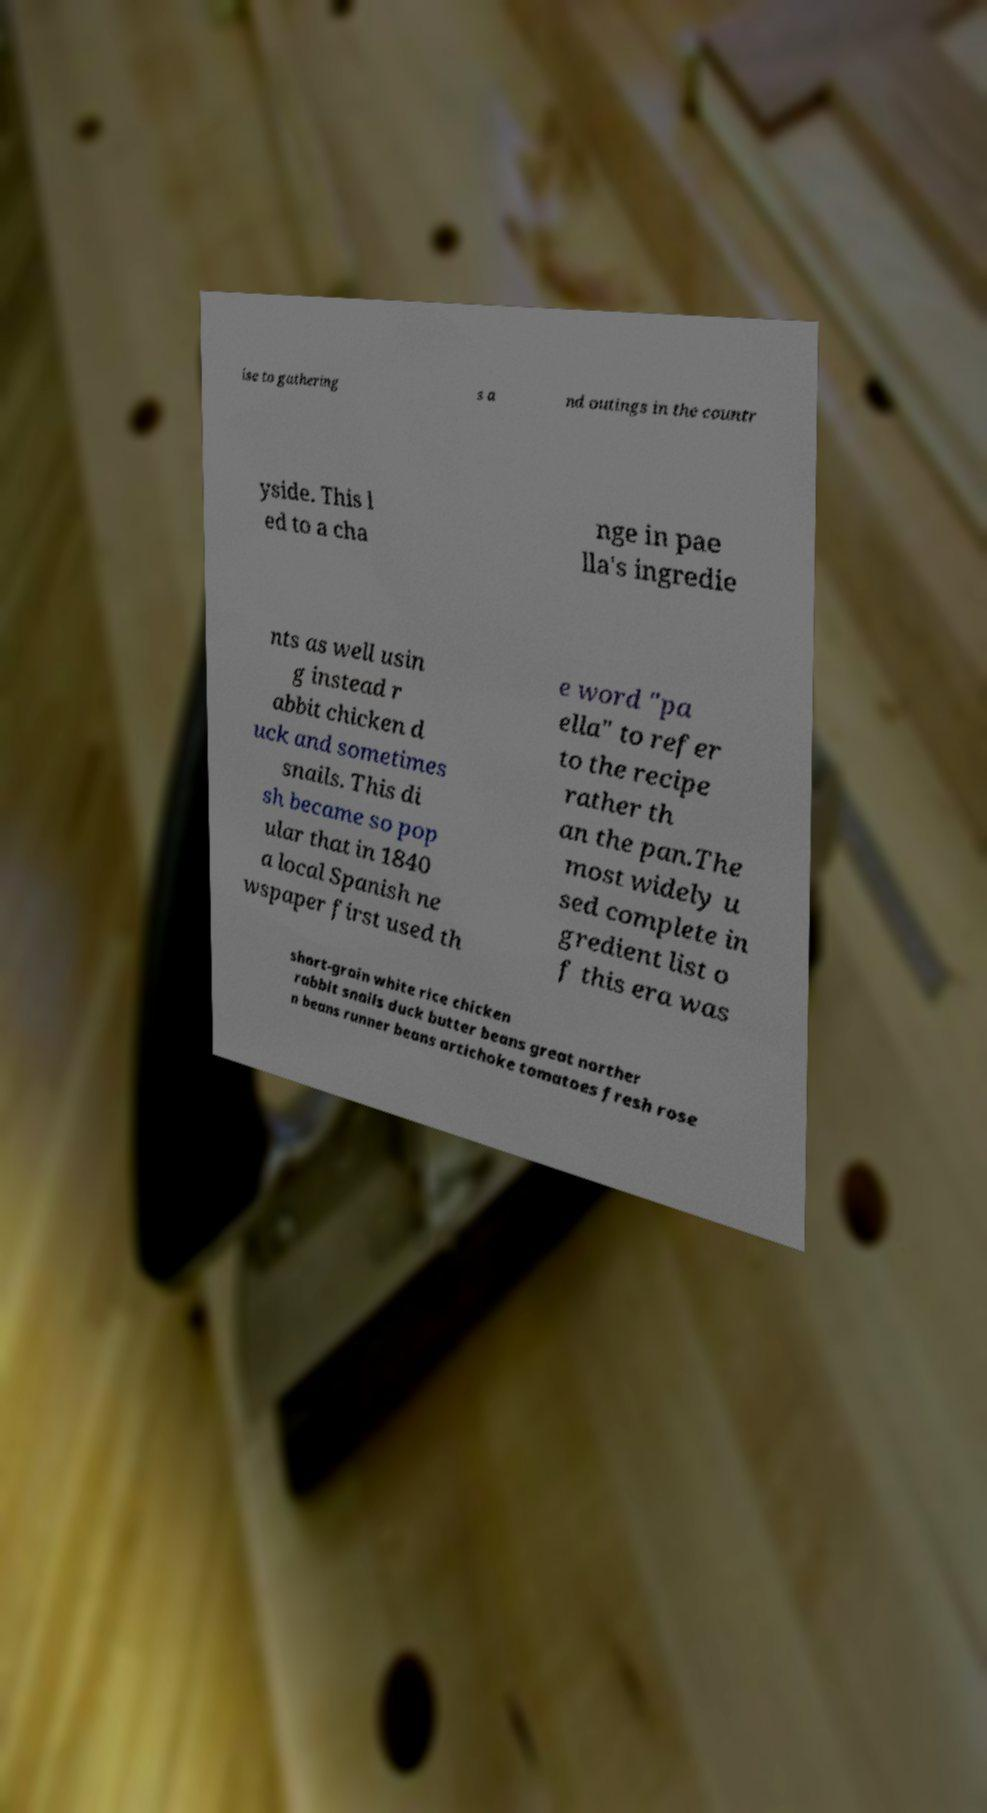Could you extract and type out the text from this image? ise to gathering s a nd outings in the countr yside. This l ed to a cha nge in pae lla's ingredie nts as well usin g instead r abbit chicken d uck and sometimes snails. This di sh became so pop ular that in 1840 a local Spanish ne wspaper first used th e word "pa ella" to refer to the recipe rather th an the pan.The most widely u sed complete in gredient list o f this era was short-grain white rice chicken rabbit snails duck butter beans great norther n beans runner beans artichoke tomatoes fresh rose 